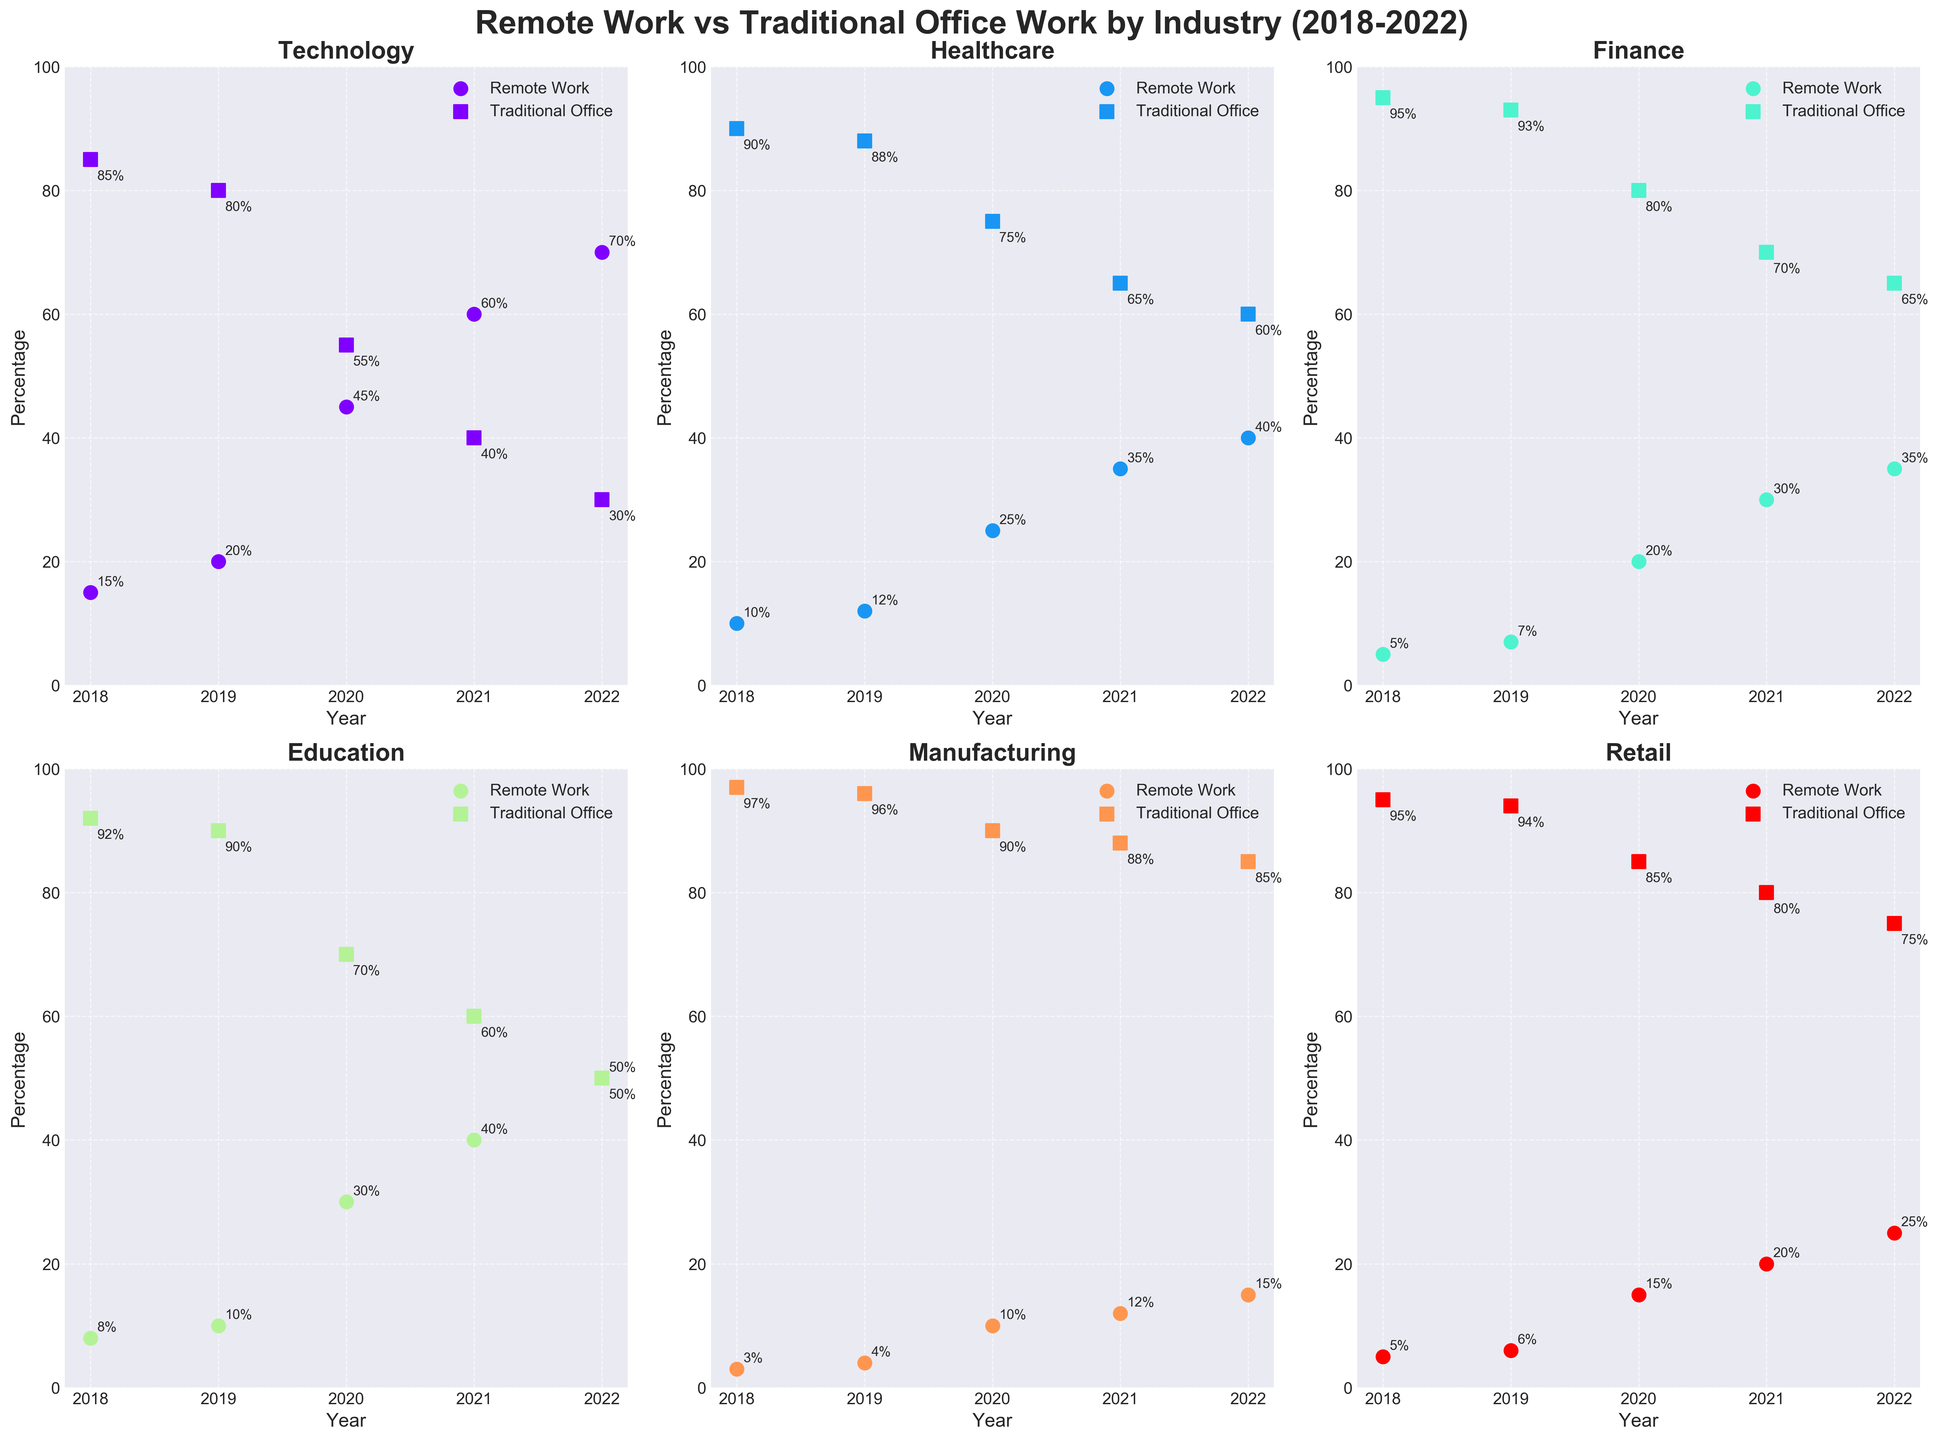What's the title of the subplot figure? The title is usually located at the top center of the figure. It is meant to give an overarching description of the data being visualized.
Answer: Remote Work vs Traditional Office Work by Industry (2018-2022) How many years of data are displayed for each industry? Each subplot represents the adoption of remote work and traditional office work from 2018 to 2022. If you count the years displayed on the x-axis, there are 5 years.
Answer: 5 years Which industry had the highest adoption of remote work in 2022? Look at the scatter points for remote work adoption in 2022 across all subplots. The most elevated point in any subplot represents the maximum adoption.
Answer: Technology Which industries saw a continuous increase in remote work adoption from 2018 to 2022? For each subplot, if the remote work adoption percentage increases year-over-year without any decrease, that industry exhibits a continuous increase in remote work adoption.
Answer: Technology, Healthcare, Education, Retail Between 2020 and 2021, which industry had the largest increase in remote work adoption? Compare the increase in remote work adoption percentages for each industry between 2020 and 2021. The largest difference indicates the industry with the highest increase.
Answer: Technology How did the traditional office work percentage change over time for the Manufacturing industry? Examine the subplot for the Manufacturing industry and observe the traditional office work data points over the years from 2018 to 2022. Note the annual changes to determine the trend.
Answer: Decreased What is the general trend for remote work adoption in the Finance industry from 2018 to 2022? Look at the remote work adoption data points for the Finance industry and identify if those points are moving upward, downward, or remain unchanged over the years.
Answer: Increased Which industry had the least change in traditional office work percentage from 2018 to 2022? Compare the traditional office work percentages in 2018 and 2022 for all industries. The industry with the smallest difference has the least change.
Answer: Manufacturing In 2020, which industry had the highest combined percentage of remote work and traditional office work? Add the percentages of remote work and traditional office work for each industry in 2020. The highest combined value will determine the answer.
Answer: Technology Which industry's trend indicates an equal percentage of remote work and traditional office work in the near future based on the current patterns? Look for the industry with converging trends where both remote work and traditional office work percentages are moving towards 50%, indicating equal adoption.
Answer: Education 